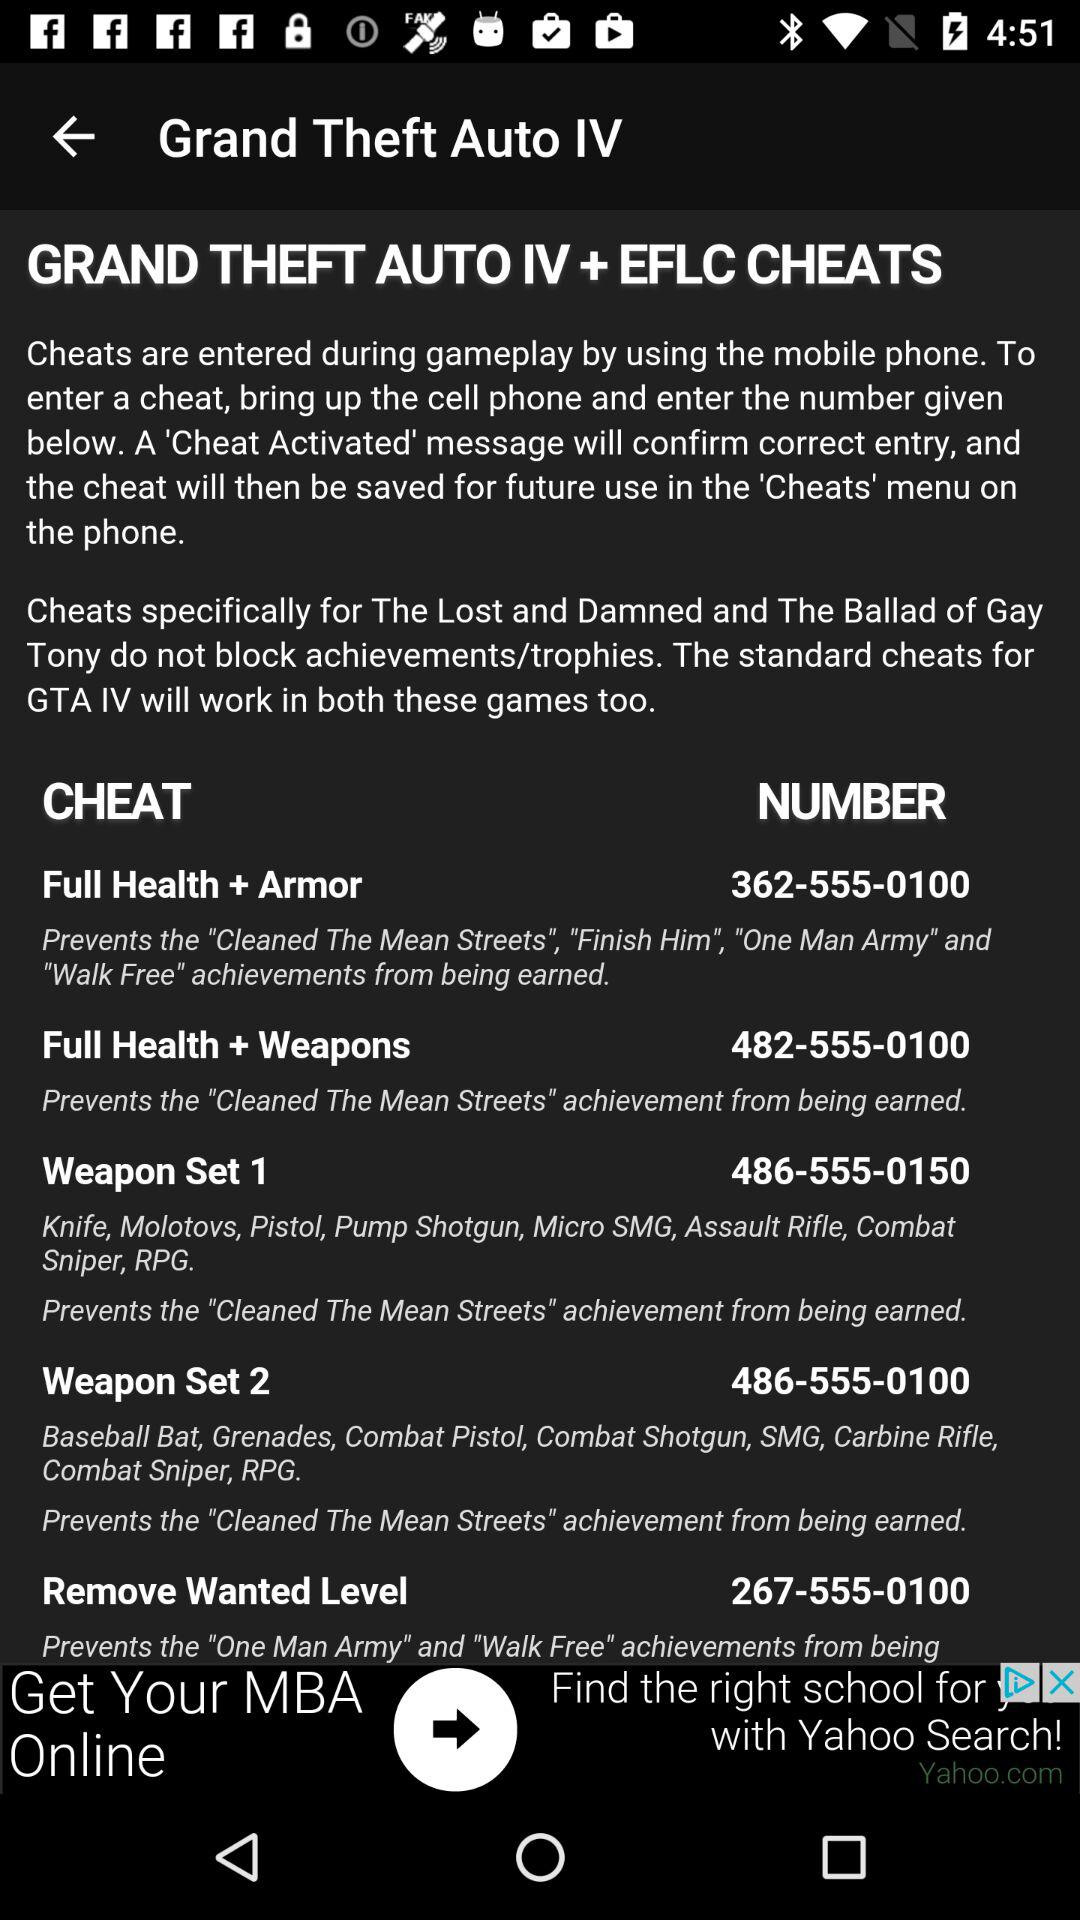What is the number to save the cheat "Weapon Set 1"? The number is 486-555-0150. 